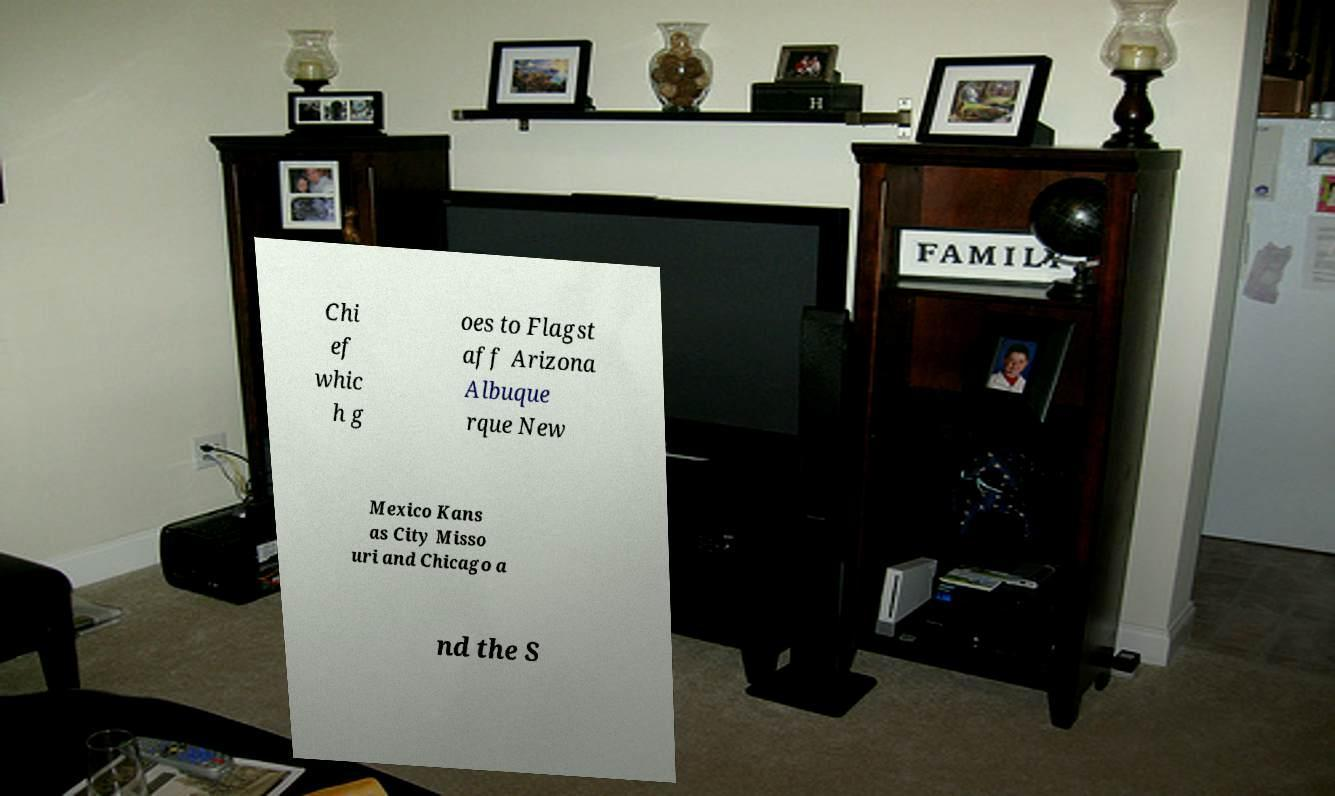Could you assist in decoding the text presented in this image and type it out clearly? Chi ef whic h g oes to Flagst aff Arizona Albuque rque New Mexico Kans as City Misso uri and Chicago a nd the S 